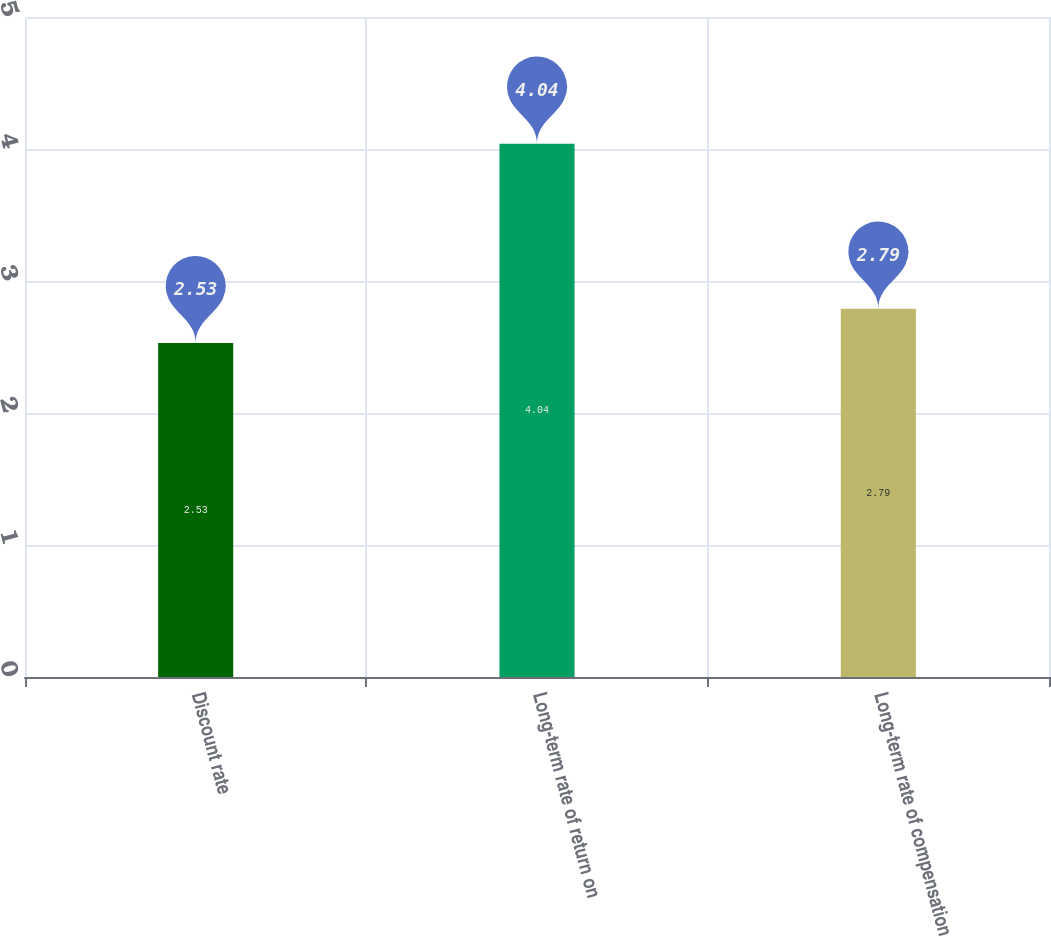Convert chart to OTSL. <chart><loc_0><loc_0><loc_500><loc_500><bar_chart><fcel>Discount rate<fcel>Long-term rate of return on<fcel>Long-term rate of compensation<nl><fcel>2.53<fcel>4.04<fcel>2.79<nl></chart> 